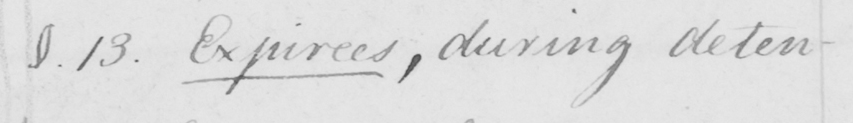Transcribe the text shown in this historical manuscript line. §.13 . Expirees ,  during deten- 